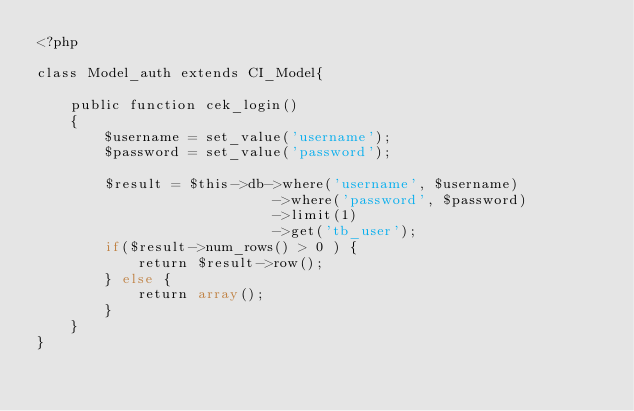<code> <loc_0><loc_0><loc_500><loc_500><_PHP_><?php

class Model_auth extends CI_Model{

    public function cek_login()
    {
        $username = set_value('username');
        $password = set_value('password');

        $result = $this->db->where('username', $username)
                            ->where('password', $password)
                            ->limit(1)
                            ->get('tb_user');
        if($result->num_rows() > 0 ) {
            return $result->row();
        } else {
            return array();
        }
    }
}</code> 